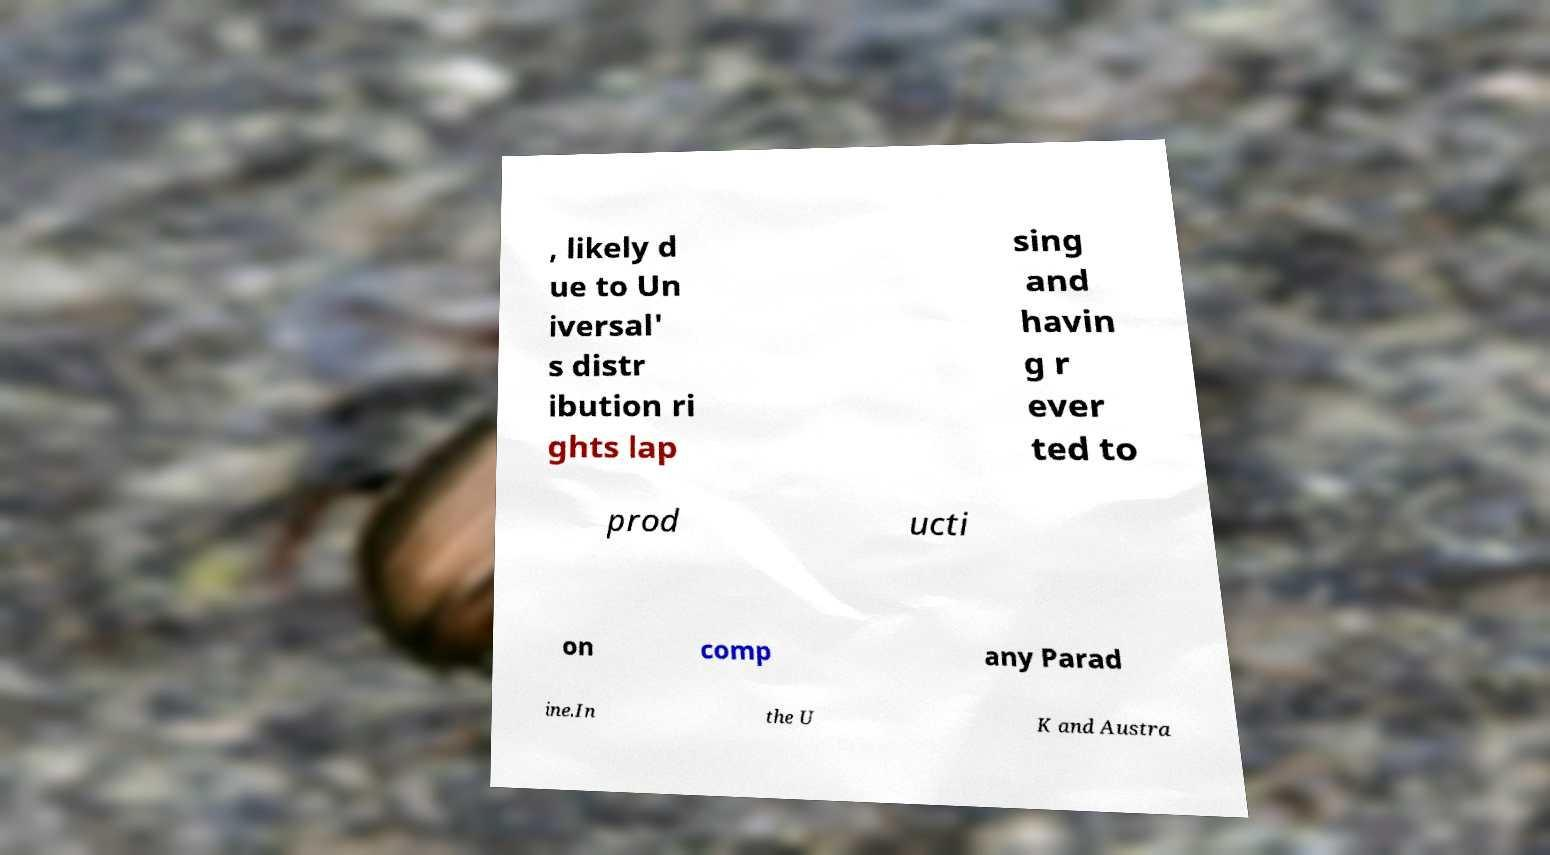Please identify and transcribe the text found in this image. , likely d ue to Un iversal' s distr ibution ri ghts lap sing and havin g r ever ted to prod ucti on comp any Parad ine.In the U K and Austra 